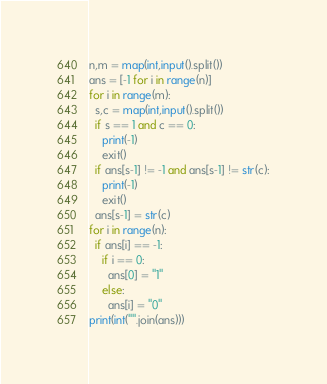Convert code to text. <code><loc_0><loc_0><loc_500><loc_500><_Python_>n,m = map(int,input().split())
ans = [-1 for i in range(n)]
for i in range(m):
  s,c = map(int,input().split())
  if s == 1 and c == 0:
    print(-1)
    exit()
  if ans[s-1] != -1 and ans[s-1] != str(c):
    print(-1)
    exit()
  ans[s-1] = str(c)
for i in range(n):
  if ans[i] == -1:
    if i == 0:
      ans[0] = "1"
    else:
      ans[i] = "0"
print(int("".join(ans)))</code> 